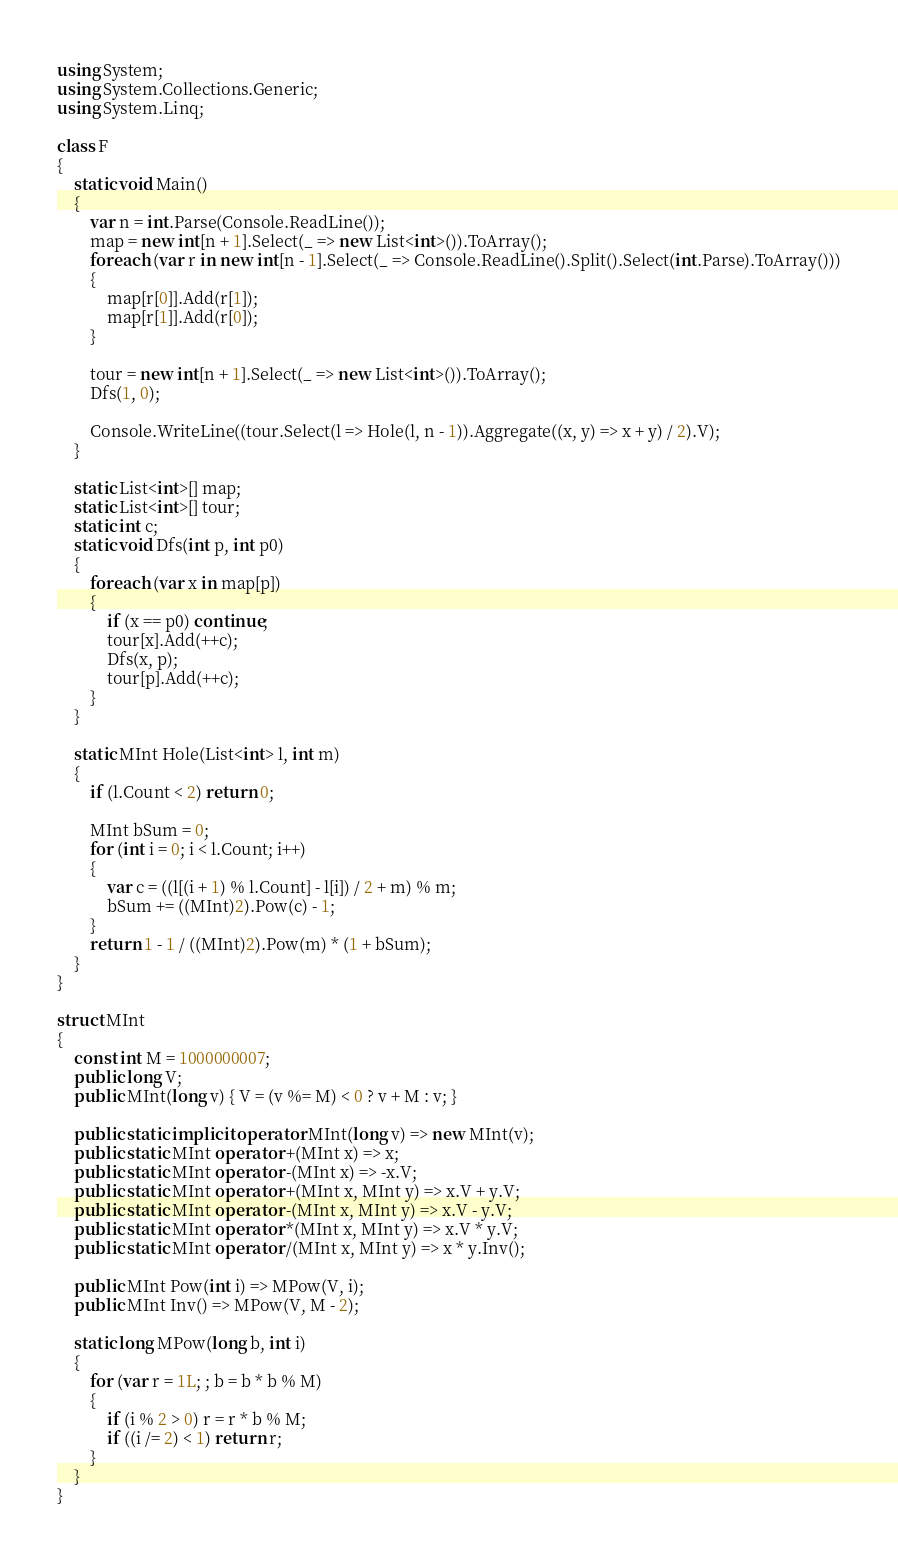Convert code to text. <code><loc_0><loc_0><loc_500><loc_500><_C#_>using System;
using System.Collections.Generic;
using System.Linq;

class F
{
	static void Main()
	{
		var n = int.Parse(Console.ReadLine());
		map = new int[n + 1].Select(_ => new List<int>()).ToArray();
		foreach (var r in new int[n - 1].Select(_ => Console.ReadLine().Split().Select(int.Parse).ToArray()))
		{
			map[r[0]].Add(r[1]);
			map[r[1]].Add(r[0]);
		}

		tour = new int[n + 1].Select(_ => new List<int>()).ToArray();
		Dfs(1, 0);

		Console.WriteLine((tour.Select(l => Hole(l, n - 1)).Aggregate((x, y) => x + y) / 2).V);
	}

	static List<int>[] map;
	static List<int>[] tour;
	static int c;
	static void Dfs(int p, int p0)
	{
		foreach (var x in map[p])
		{
			if (x == p0) continue;
			tour[x].Add(++c);
			Dfs(x, p);
			tour[p].Add(++c);
		}
	}

	static MInt Hole(List<int> l, int m)
	{
		if (l.Count < 2) return 0;

		MInt bSum = 0;
		for (int i = 0; i < l.Count; i++)
		{
			var c = ((l[(i + 1) % l.Count] - l[i]) / 2 + m) % m;
			bSum += ((MInt)2).Pow(c) - 1;
		}
		return 1 - 1 / ((MInt)2).Pow(m) * (1 + bSum);
	}
}

struct MInt
{
	const int M = 1000000007;
	public long V;
	public MInt(long v) { V = (v %= M) < 0 ? v + M : v; }

	public static implicit operator MInt(long v) => new MInt(v);
	public static MInt operator +(MInt x) => x;
	public static MInt operator -(MInt x) => -x.V;
	public static MInt operator +(MInt x, MInt y) => x.V + y.V;
	public static MInt operator -(MInt x, MInt y) => x.V - y.V;
	public static MInt operator *(MInt x, MInt y) => x.V * y.V;
	public static MInt operator /(MInt x, MInt y) => x * y.Inv();

	public MInt Pow(int i) => MPow(V, i);
	public MInt Inv() => MPow(V, M - 2);

	static long MPow(long b, int i)
	{
		for (var r = 1L; ; b = b * b % M)
		{
			if (i % 2 > 0) r = r * b % M;
			if ((i /= 2) < 1) return r;
		}
	}
}
</code> 